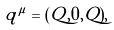<formula> <loc_0><loc_0><loc_500><loc_500>q ^ { \mu } = ( Q , 0 , Q ) ,</formula> 